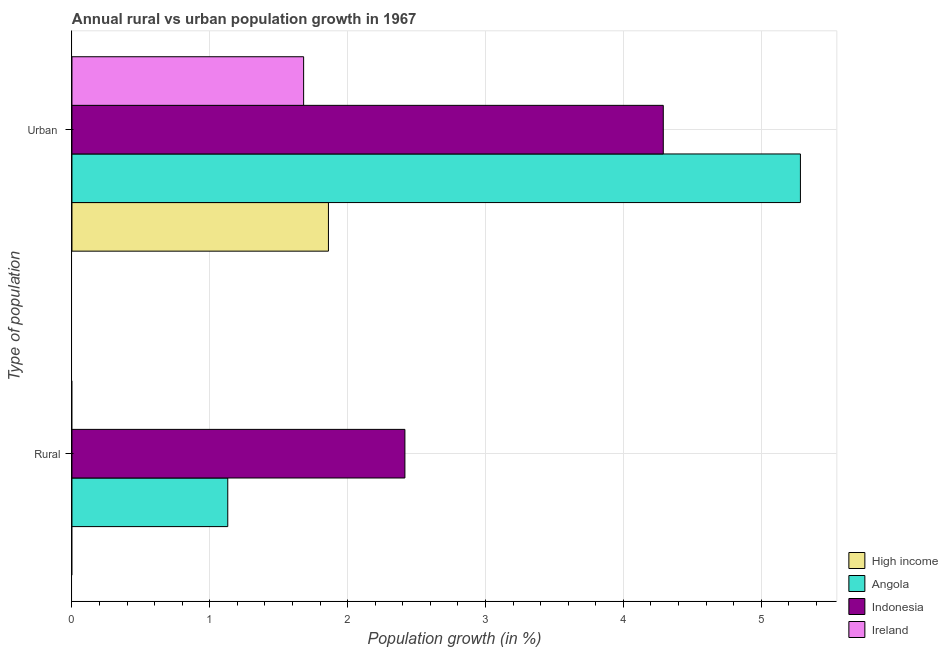How many different coloured bars are there?
Your answer should be very brief. 4. How many groups of bars are there?
Give a very brief answer. 2. Are the number of bars per tick equal to the number of legend labels?
Make the answer very short. No. How many bars are there on the 1st tick from the bottom?
Keep it short and to the point. 2. What is the label of the 2nd group of bars from the top?
Keep it short and to the point. Rural. What is the urban population growth in High income?
Your answer should be compact. 1.86. Across all countries, what is the maximum rural population growth?
Keep it short and to the point. 2.42. Across all countries, what is the minimum urban population growth?
Your answer should be compact. 1.68. In which country was the rural population growth maximum?
Provide a short and direct response. Indonesia. What is the total urban population growth in the graph?
Provide a succinct answer. 13.11. What is the difference between the urban population growth in High income and that in Ireland?
Ensure brevity in your answer.  0.18. What is the difference between the rural population growth in Indonesia and the urban population growth in High income?
Keep it short and to the point. 0.55. What is the average rural population growth per country?
Your answer should be very brief. 0.89. What is the difference between the rural population growth and urban population growth in Angola?
Provide a succinct answer. -4.15. In how many countries, is the rural population growth greater than 2.2 %?
Make the answer very short. 1. What is the ratio of the urban population growth in Ireland to that in Angola?
Offer a terse response. 0.32. Is the urban population growth in Ireland less than that in High income?
Keep it short and to the point. Yes. Are all the bars in the graph horizontal?
Give a very brief answer. Yes. What is the difference between two consecutive major ticks on the X-axis?
Give a very brief answer. 1. Are the values on the major ticks of X-axis written in scientific E-notation?
Your answer should be very brief. No. Does the graph contain any zero values?
Ensure brevity in your answer.  Yes. Does the graph contain grids?
Your response must be concise. Yes. Where does the legend appear in the graph?
Your answer should be very brief. Bottom right. What is the title of the graph?
Provide a short and direct response. Annual rural vs urban population growth in 1967. Does "Tajikistan" appear as one of the legend labels in the graph?
Offer a terse response. No. What is the label or title of the X-axis?
Provide a short and direct response. Population growth (in %). What is the label or title of the Y-axis?
Your response must be concise. Type of population. What is the Population growth (in %) of High income in Rural?
Your answer should be compact. 0. What is the Population growth (in %) of Angola in Rural?
Offer a very short reply. 1.13. What is the Population growth (in %) in Indonesia in Rural?
Your answer should be very brief. 2.42. What is the Population growth (in %) of Ireland in Rural?
Offer a very short reply. 0. What is the Population growth (in %) of High income in Urban ?
Ensure brevity in your answer.  1.86. What is the Population growth (in %) of Angola in Urban ?
Make the answer very short. 5.28. What is the Population growth (in %) of Indonesia in Urban ?
Your answer should be compact. 4.29. What is the Population growth (in %) in Ireland in Urban ?
Give a very brief answer. 1.68. Across all Type of population, what is the maximum Population growth (in %) in High income?
Make the answer very short. 1.86. Across all Type of population, what is the maximum Population growth (in %) in Angola?
Your answer should be very brief. 5.28. Across all Type of population, what is the maximum Population growth (in %) in Indonesia?
Make the answer very short. 4.29. Across all Type of population, what is the maximum Population growth (in %) in Ireland?
Give a very brief answer. 1.68. Across all Type of population, what is the minimum Population growth (in %) in Angola?
Provide a succinct answer. 1.13. Across all Type of population, what is the minimum Population growth (in %) in Indonesia?
Provide a succinct answer. 2.42. Across all Type of population, what is the minimum Population growth (in %) in Ireland?
Provide a short and direct response. 0. What is the total Population growth (in %) of High income in the graph?
Provide a succinct answer. 1.86. What is the total Population growth (in %) of Angola in the graph?
Your response must be concise. 6.41. What is the total Population growth (in %) of Indonesia in the graph?
Offer a very short reply. 6.7. What is the total Population growth (in %) in Ireland in the graph?
Ensure brevity in your answer.  1.68. What is the difference between the Population growth (in %) of Angola in Rural and that in Urban ?
Offer a very short reply. -4.15. What is the difference between the Population growth (in %) of Indonesia in Rural and that in Urban ?
Ensure brevity in your answer.  -1.87. What is the difference between the Population growth (in %) in Angola in Rural and the Population growth (in %) in Indonesia in Urban ?
Keep it short and to the point. -3.16. What is the difference between the Population growth (in %) of Angola in Rural and the Population growth (in %) of Ireland in Urban ?
Keep it short and to the point. -0.55. What is the difference between the Population growth (in %) of Indonesia in Rural and the Population growth (in %) of Ireland in Urban ?
Your response must be concise. 0.73. What is the average Population growth (in %) in High income per Type of population?
Your response must be concise. 0.93. What is the average Population growth (in %) of Angola per Type of population?
Keep it short and to the point. 3.21. What is the average Population growth (in %) in Indonesia per Type of population?
Ensure brevity in your answer.  3.35. What is the average Population growth (in %) of Ireland per Type of population?
Provide a short and direct response. 0.84. What is the difference between the Population growth (in %) in Angola and Population growth (in %) in Indonesia in Rural?
Offer a very short reply. -1.28. What is the difference between the Population growth (in %) of High income and Population growth (in %) of Angola in Urban ?
Your answer should be very brief. -3.42. What is the difference between the Population growth (in %) in High income and Population growth (in %) in Indonesia in Urban ?
Your answer should be compact. -2.43. What is the difference between the Population growth (in %) of High income and Population growth (in %) of Ireland in Urban ?
Provide a short and direct response. 0.18. What is the difference between the Population growth (in %) of Angola and Population growth (in %) of Indonesia in Urban ?
Offer a very short reply. 0.99. What is the difference between the Population growth (in %) in Angola and Population growth (in %) in Ireland in Urban ?
Keep it short and to the point. 3.6. What is the difference between the Population growth (in %) of Indonesia and Population growth (in %) of Ireland in Urban ?
Provide a short and direct response. 2.61. What is the ratio of the Population growth (in %) in Angola in Rural to that in Urban ?
Ensure brevity in your answer.  0.21. What is the ratio of the Population growth (in %) in Indonesia in Rural to that in Urban ?
Ensure brevity in your answer.  0.56. What is the difference between the highest and the second highest Population growth (in %) in Angola?
Ensure brevity in your answer.  4.15. What is the difference between the highest and the second highest Population growth (in %) of Indonesia?
Your answer should be compact. 1.87. What is the difference between the highest and the lowest Population growth (in %) of High income?
Make the answer very short. 1.86. What is the difference between the highest and the lowest Population growth (in %) of Angola?
Give a very brief answer. 4.15. What is the difference between the highest and the lowest Population growth (in %) of Indonesia?
Your answer should be very brief. 1.87. What is the difference between the highest and the lowest Population growth (in %) in Ireland?
Your response must be concise. 1.68. 